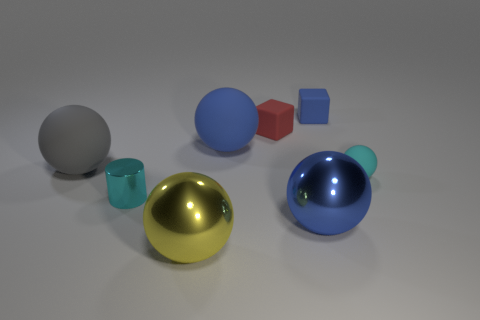There is a shiny thing that is on the right side of the big blue matte ball; is its color the same as the small rubber object that is in front of the red cube?
Keep it short and to the point. No. The blue rubber thing that is left of the tiny red thing has what shape?
Give a very brief answer. Sphere. The small shiny object has what color?
Your response must be concise. Cyan. The cyan thing that is made of the same material as the gray sphere is what shape?
Provide a succinct answer. Sphere. There is a metallic sphere behind the yellow metallic ball; is its size the same as the tiny red thing?
Offer a very short reply. No. What number of objects are either big spheres that are on the right side of the gray object or small objects that are on the right side of the tiny blue block?
Make the answer very short. 4. Does the big shiny object that is behind the big yellow shiny ball have the same color as the cylinder?
Provide a succinct answer. No. How many metal objects are either blue things or large spheres?
Your response must be concise. 2. What shape is the small shiny object?
Provide a succinct answer. Cylinder. Is there any other thing that has the same material as the small red object?
Make the answer very short. Yes. 